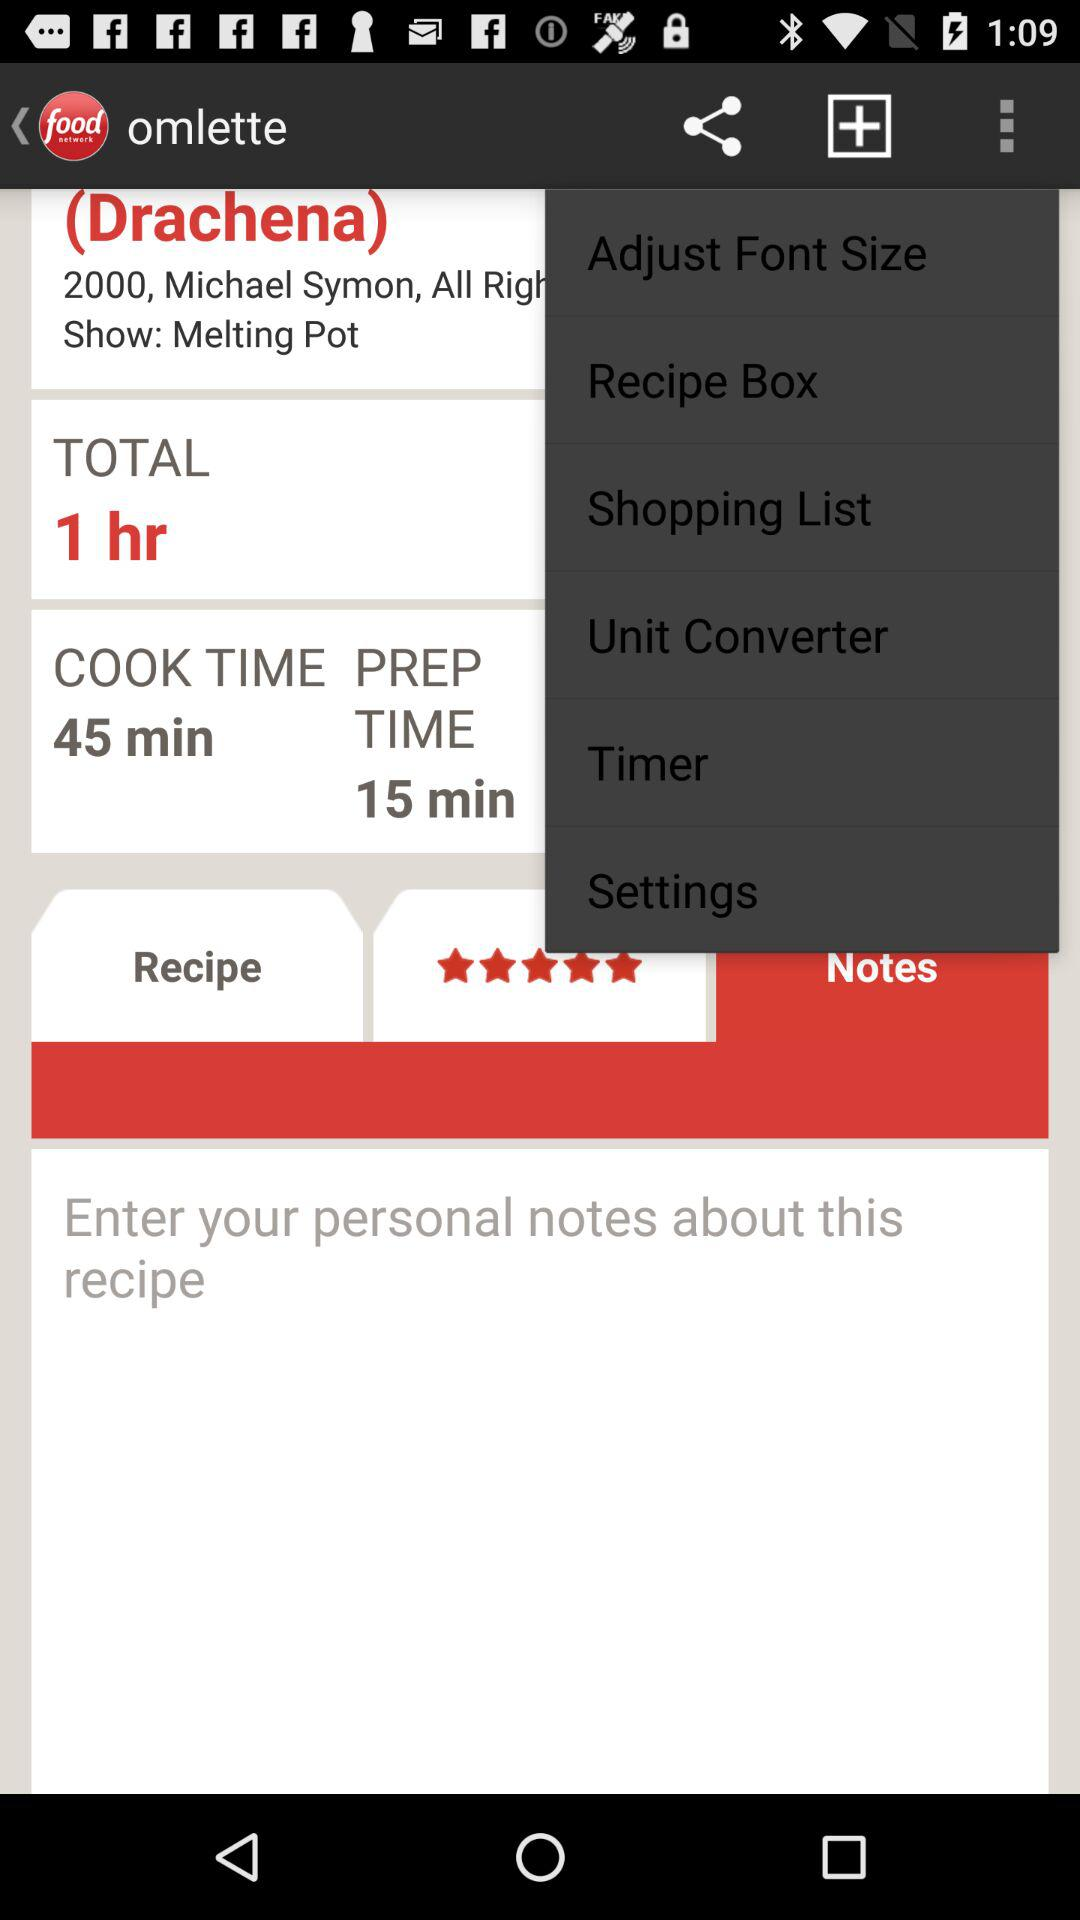What is the name of the application? The name of the application is "Food Network". 